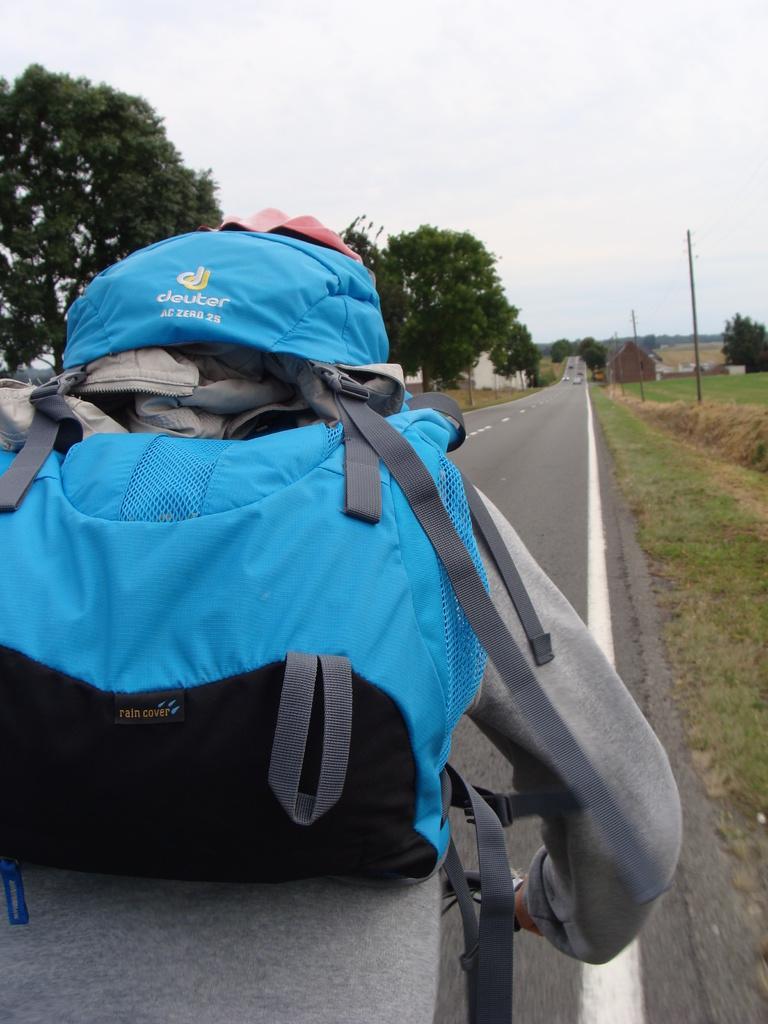Can you describe this image briefly? In this picture a street on which there is a person with blue color backpack and also we can see some grass and trees around. 